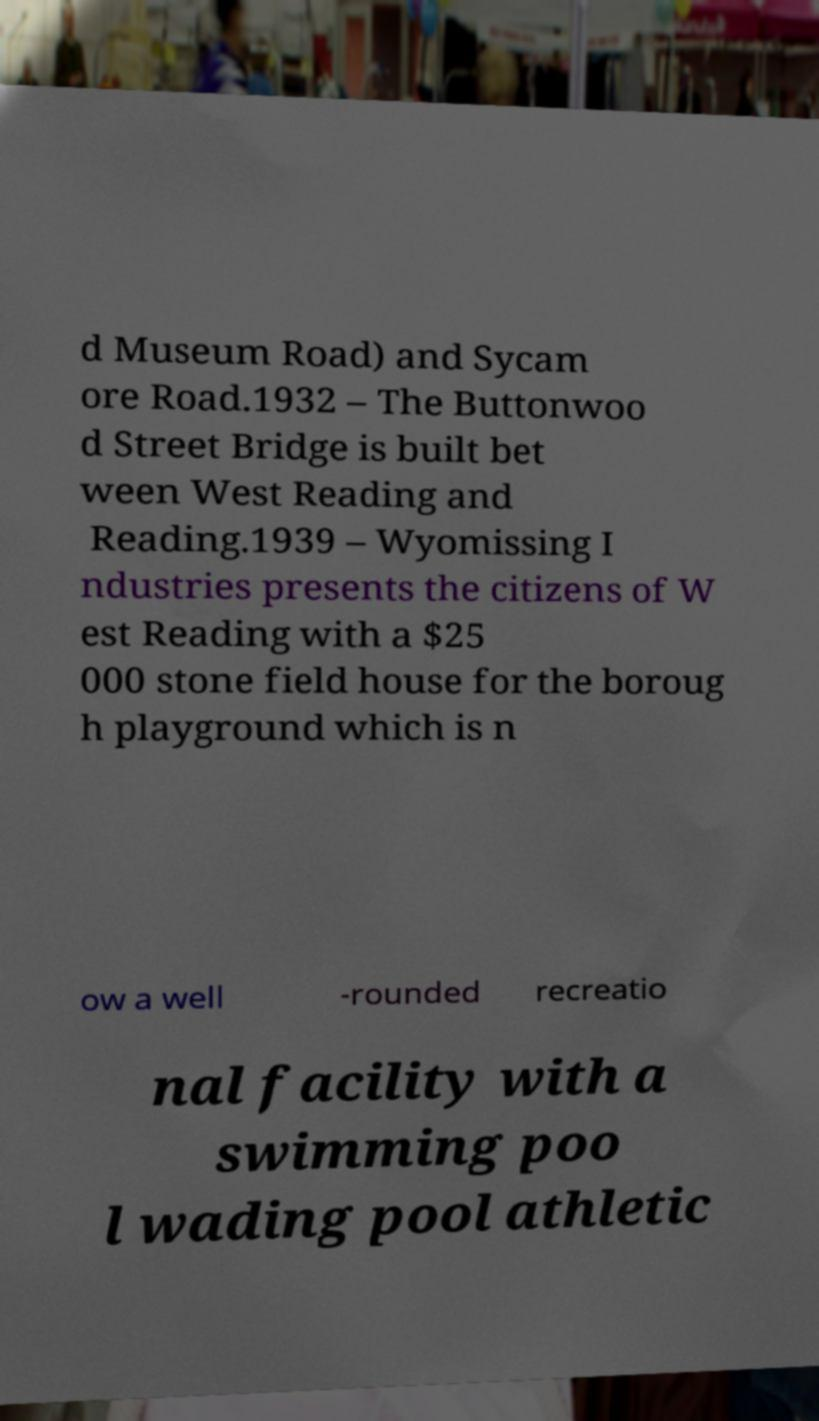For documentation purposes, I need the text within this image transcribed. Could you provide that? d Museum Road) and Sycam ore Road.1932 – The Buttonwoo d Street Bridge is built bet ween West Reading and Reading.1939 – Wyomissing I ndustries presents the citizens of W est Reading with a $25 000 stone field house for the boroug h playground which is n ow a well -rounded recreatio nal facility with a swimming poo l wading pool athletic 